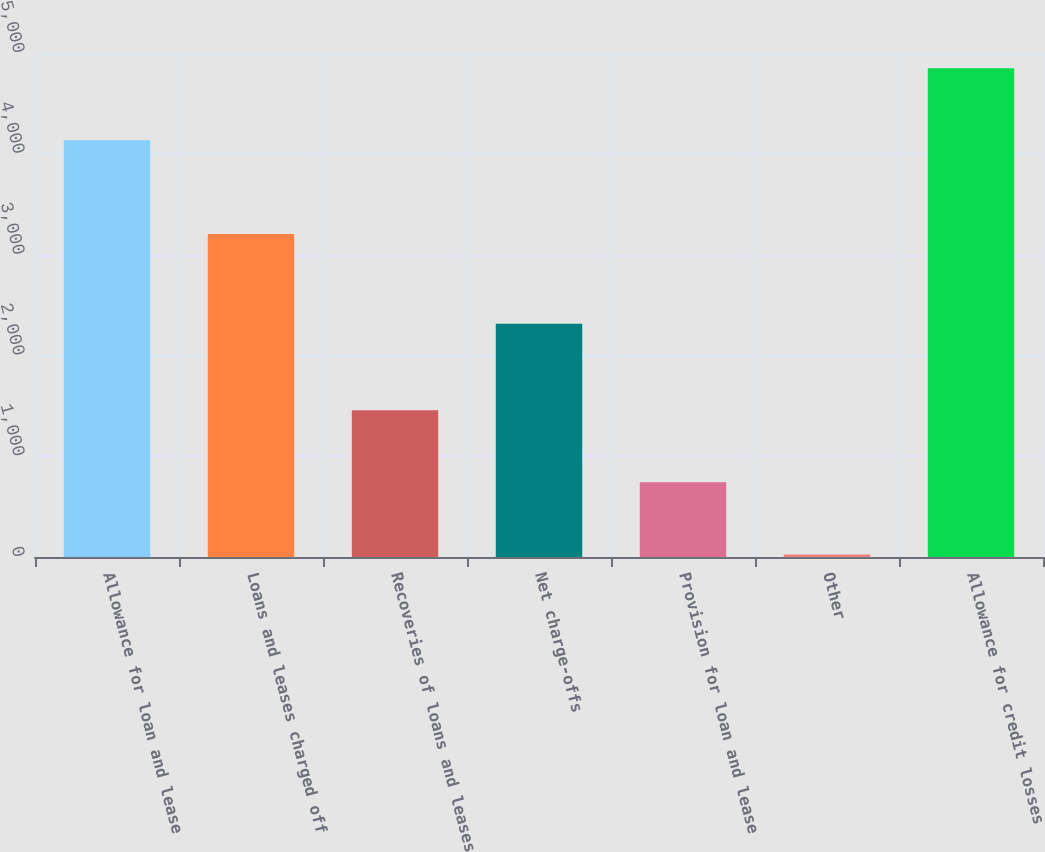Convert chart to OTSL. <chart><loc_0><loc_0><loc_500><loc_500><bar_chart><fcel>Allowance for loan and lease<fcel>Loans and leases charged off<fcel>Recoveries of loans and leases<fcel>Net charge-offs<fcel>Provision for loan and lease<fcel>Other<fcel>Allowance for credit losses<nl><fcel>4135<fcel>3204<fcel>1454.8<fcel>2313<fcel>740.4<fcel>26<fcel>4849.4<nl></chart> 